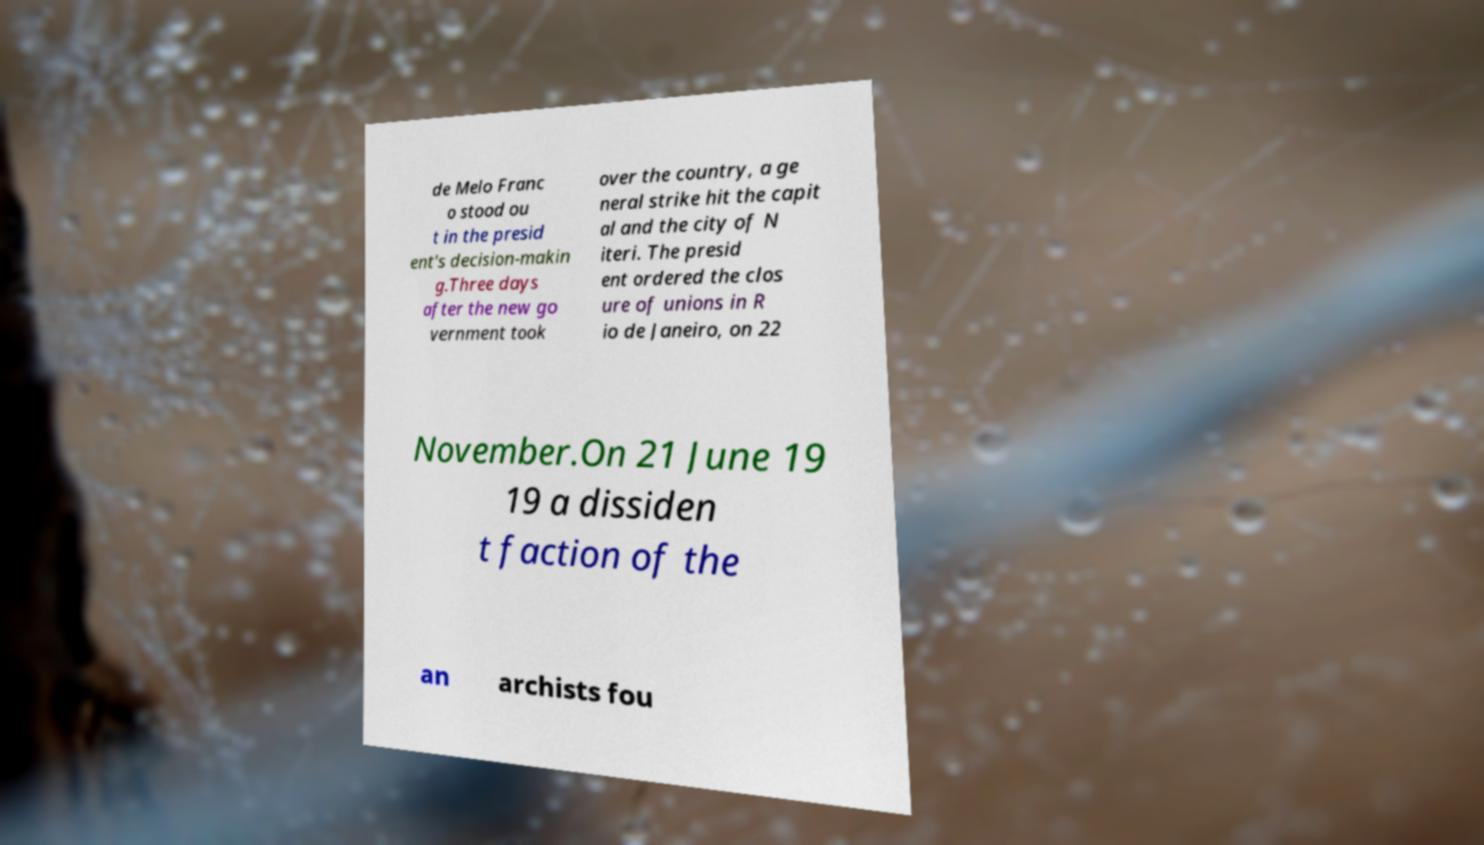Please read and relay the text visible in this image. What does it say? de Melo Franc o stood ou t in the presid ent's decision-makin g.Three days after the new go vernment took over the country, a ge neral strike hit the capit al and the city of N iteri. The presid ent ordered the clos ure of unions in R io de Janeiro, on 22 November.On 21 June 19 19 a dissiden t faction of the an archists fou 